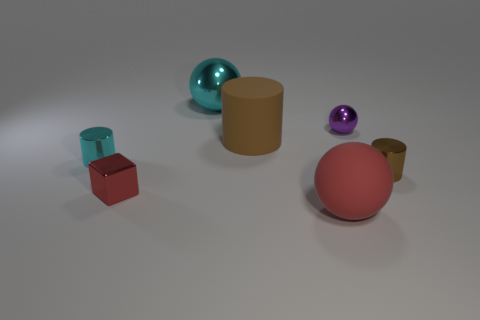Do the matte sphere and the purple thing have the same size?
Ensure brevity in your answer.  No. What number of big red balls have the same material as the large cylinder?
Make the answer very short. 1. There is a cyan metal thing that is the same shape as the brown matte object; what is its size?
Ensure brevity in your answer.  Small. Is the shape of the small thing that is behind the big brown cylinder the same as  the small cyan object?
Your response must be concise. No. What shape is the big matte thing behind the tiny metallic cylinder on the left side of the tiny sphere?
Provide a succinct answer. Cylinder. Is there anything else that has the same shape as the big metallic object?
Ensure brevity in your answer.  Yes. What color is the other tiny object that is the same shape as the red rubber thing?
Offer a very short reply. Purple. Is the color of the big shiny thing the same as the matte object in front of the big brown matte cylinder?
Make the answer very short. No. There is a large object that is behind the red metallic thing and in front of the purple sphere; what shape is it?
Offer a terse response. Cylinder. Is the number of yellow objects less than the number of big brown objects?
Keep it short and to the point. Yes. 